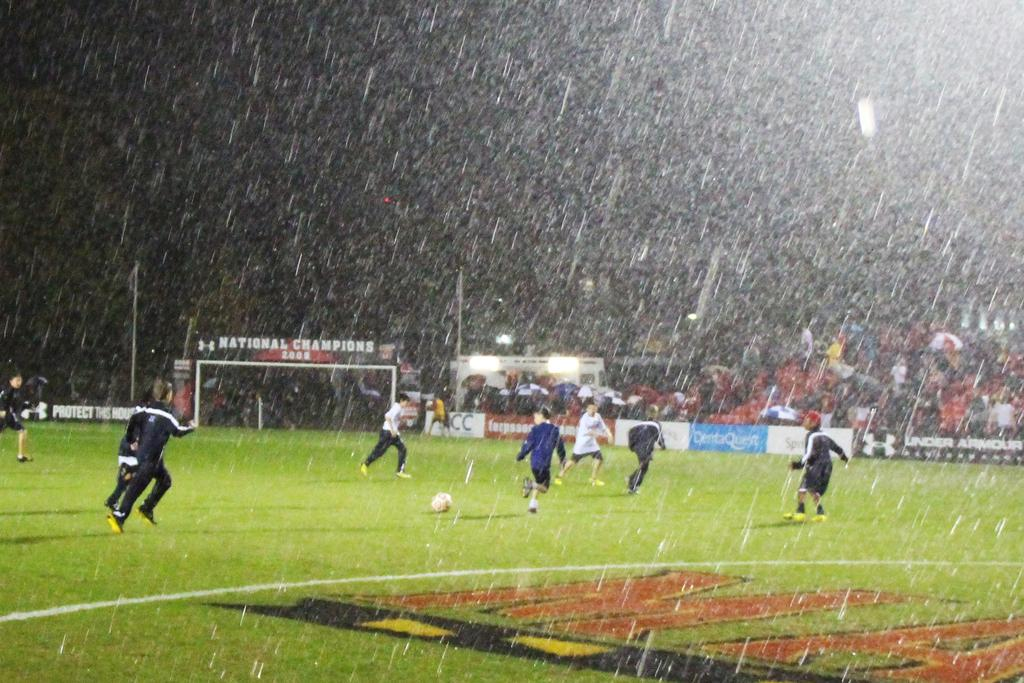Provide a one-sentence caption for the provided image. People playing in the rain in a stadium with an sign that says national champions. 